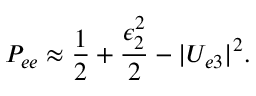Convert formula to latex. <formula><loc_0><loc_0><loc_500><loc_500>P _ { e e } \approx \frac { 1 } { 2 } + \frac { \epsilon _ { 2 } ^ { 2 } } { 2 } - | U _ { e 3 } | ^ { 2 } .</formula> 